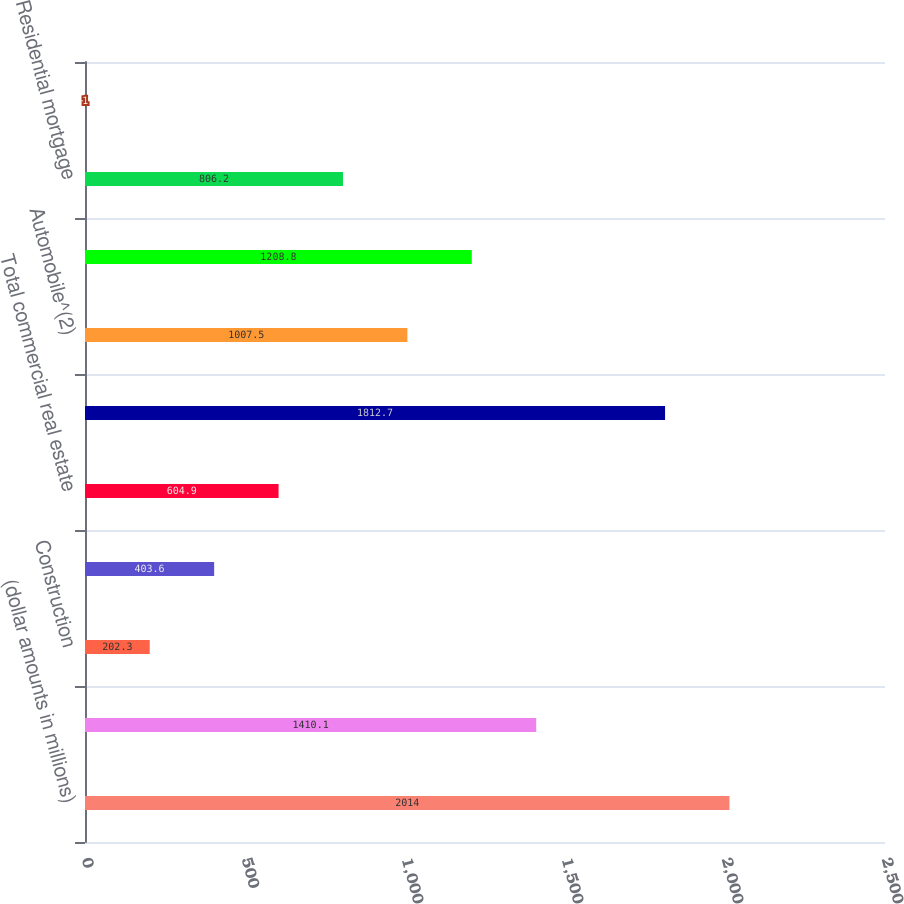Convert chart to OTSL. <chart><loc_0><loc_0><loc_500><loc_500><bar_chart><fcel>(dollar amounts in millions)<fcel>Commercial and industrial<fcel>Construction<fcel>Commercial<fcel>Total commercial real estate<fcel>Total commercial<fcel>Automobile^(2)<fcel>Home equity<fcel>Residential mortgage<fcel>Other consumer<nl><fcel>2014<fcel>1410.1<fcel>202.3<fcel>403.6<fcel>604.9<fcel>1812.7<fcel>1007.5<fcel>1208.8<fcel>806.2<fcel>1<nl></chart> 